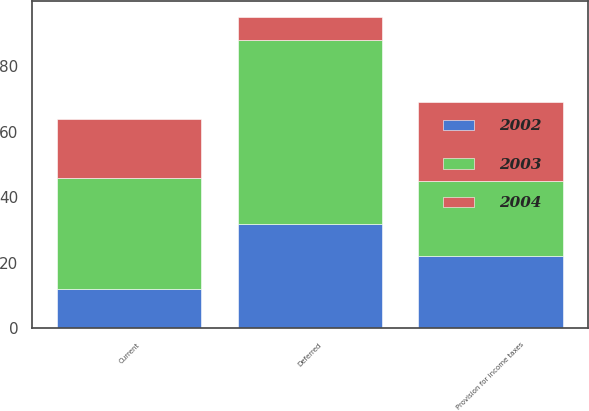<chart> <loc_0><loc_0><loc_500><loc_500><stacked_bar_chart><ecel><fcel>Current<fcel>Deferred<fcel>Provision for income taxes<nl><fcel>2003<fcel>34<fcel>56<fcel>23<nl><fcel>2004<fcel>18<fcel>7<fcel>24<nl><fcel>2002<fcel>12<fcel>32<fcel>22<nl></chart> 